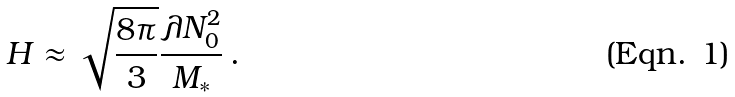Convert formula to latex. <formula><loc_0><loc_0><loc_500><loc_500>H \approx \sqrt { \frac { 8 \pi } { 3 } } \frac { \lambda N _ { 0 } ^ { 2 } } { M _ { \ast } } \, .</formula> 